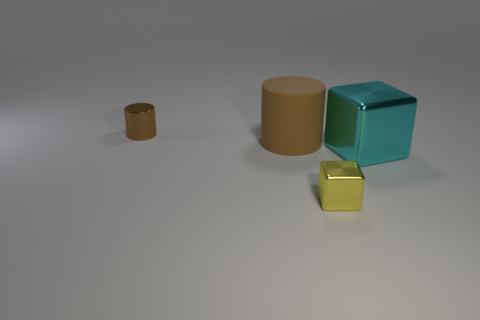Add 1 small metallic cylinders. How many objects exist? 5 Subtract all cyan blocks. How many blocks are left? 1 Add 2 matte objects. How many matte objects are left? 3 Add 2 big cyan shiny blocks. How many big cyan shiny blocks exist? 3 Subtract 1 cyan cubes. How many objects are left? 3 Subtract all green shiny cylinders. Subtract all brown metallic objects. How many objects are left? 3 